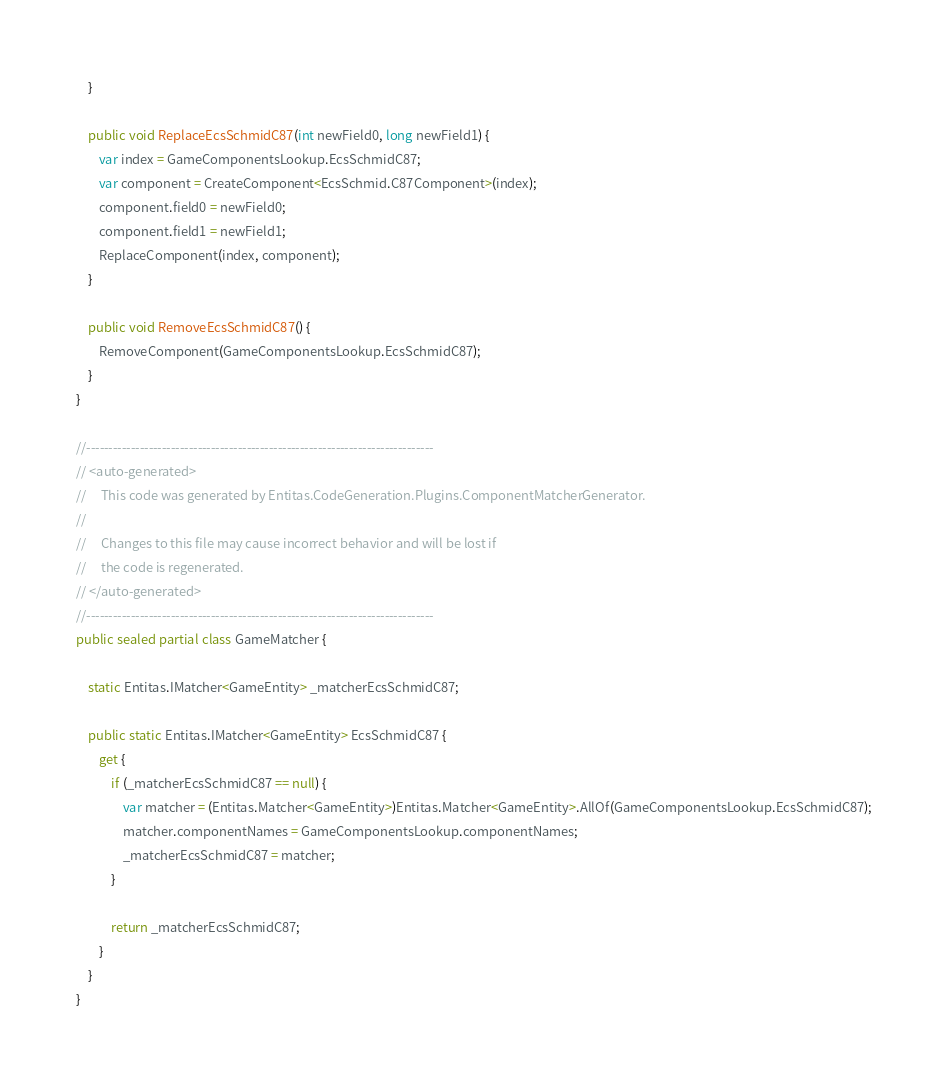Convert code to text. <code><loc_0><loc_0><loc_500><loc_500><_C#_>    }

    public void ReplaceEcsSchmidC87(int newField0, long newField1) {
        var index = GameComponentsLookup.EcsSchmidC87;
        var component = CreateComponent<EcsSchmid.C87Component>(index);
        component.field0 = newField0;
        component.field1 = newField1;
        ReplaceComponent(index, component);
    }

    public void RemoveEcsSchmidC87() {
        RemoveComponent(GameComponentsLookup.EcsSchmidC87);
    }
}

//------------------------------------------------------------------------------
// <auto-generated>
//     This code was generated by Entitas.CodeGeneration.Plugins.ComponentMatcherGenerator.
//
//     Changes to this file may cause incorrect behavior and will be lost if
//     the code is regenerated.
// </auto-generated>
//------------------------------------------------------------------------------
public sealed partial class GameMatcher {

    static Entitas.IMatcher<GameEntity> _matcherEcsSchmidC87;

    public static Entitas.IMatcher<GameEntity> EcsSchmidC87 {
        get {
            if (_matcherEcsSchmidC87 == null) {
                var matcher = (Entitas.Matcher<GameEntity>)Entitas.Matcher<GameEntity>.AllOf(GameComponentsLookup.EcsSchmidC87);
                matcher.componentNames = GameComponentsLookup.componentNames;
                _matcherEcsSchmidC87 = matcher;
            }

            return _matcherEcsSchmidC87;
        }
    }
}
</code> 